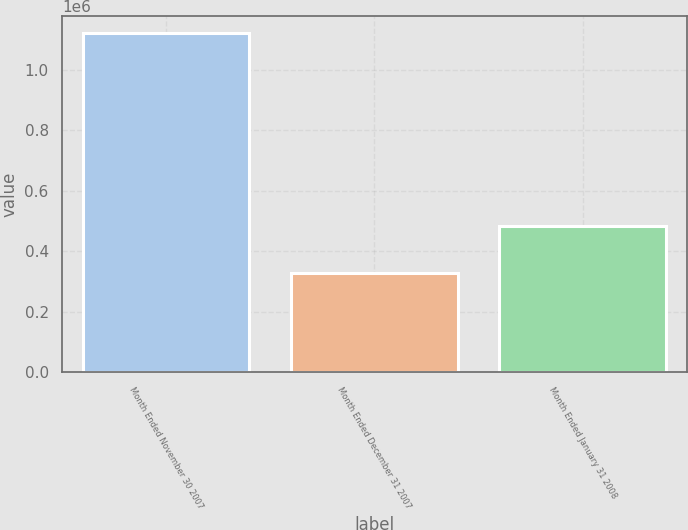<chart> <loc_0><loc_0><loc_500><loc_500><bar_chart><fcel>Month Ended November 30 2007<fcel>Month Ended December 31 2007<fcel>Month Ended January 31 2008<nl><fcel>1.1209e+06<fcel>328316<fcel>482100<nl></chart> 